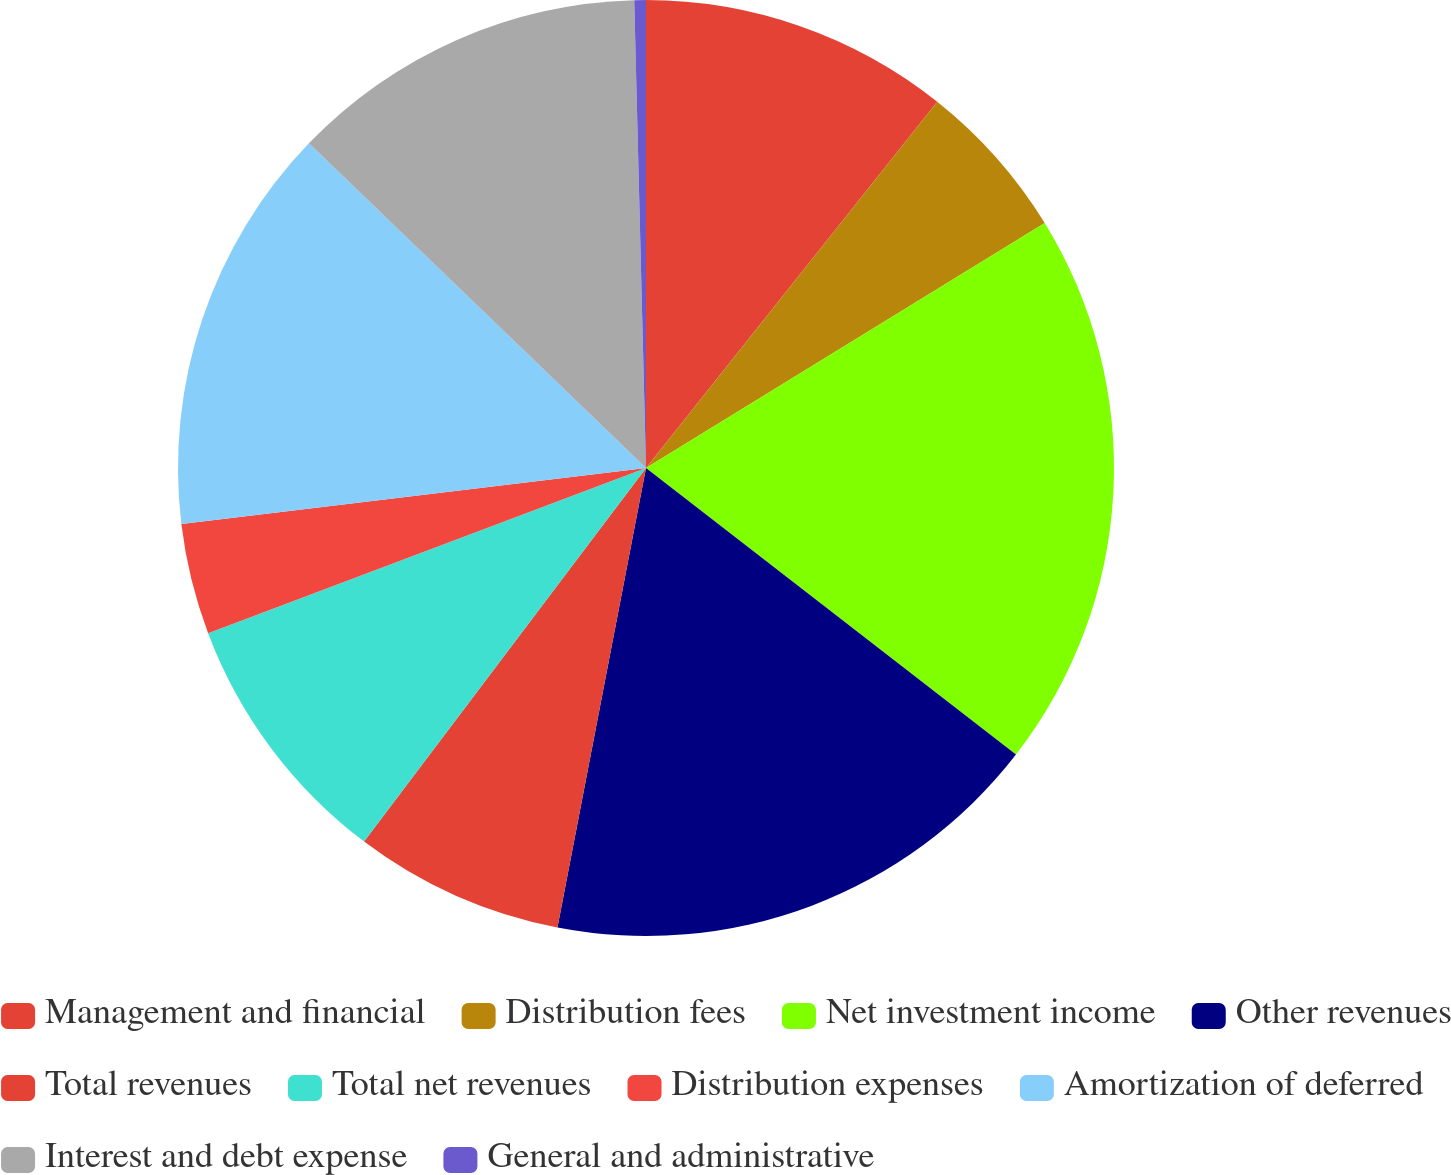Convert chart to OTSL. <chart><loc_0><loc_0><loc_500><loc_500><pie_chart><fcel>Management and financial<fcel>Distribution fees<fcel>Net investment income<fcel>Other revenues<fcel>Total revenues<fcel>Total net revenues<fcel>Distribution expenses<fcel>Amortization of deferred<fcel>Interest and debt expense<fcel>General and administrative<nl><fcel>10.69%<fcel>5.54%<fcel>19.26%<fcel>17.54%<fcel>7.26%<fcel>8.97%<fcel>3.83%<fcel>14.11%<fcel>12.4%<fcel>0.4%<nl></chart> 